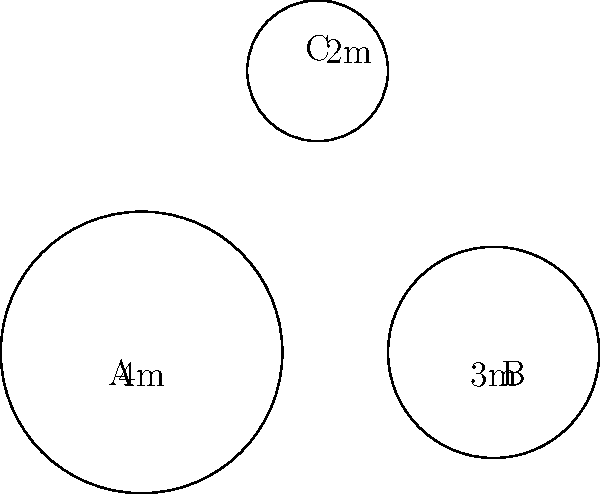You're planning to install three circular cold storage units in your online grocery store to keep fresh produce at optimal temperatures. The radii of the units are 4m, 3m, and 2m respectively, as shown in the diagram. Calculate the total floor area that these cold storage units will occupy. Round your answer to the nearest square meter. To solve this problem, we need to calculate the area of each circular cold storage unit and then sum them up. Let's go through this step-by-step:

1) The formula for the area of a circle is $A = \pi r^2$, where $r$ is the radius.

2) For the first unit (A):
   $A_1 = \pi (4m)^2 = 16\pi m^2$

3) For the second unit (B):
   $A_2 = \pi (3m)^2 = 9\pi m^2$

4) For the third unit (C):
   $A_3 = \pi (2m)^2 = 4\pi m^2$

5) Total area:
   $A_{total} = A_1 + A_2 + A_3$
   $A_{total} = 16\pi m^2 + 9\pi m^2 + 4\pi m^2$
   $A_{total} = 29\pi m^2$

6) Now, let's calculate this:
   $A_{total} = 29 \times 3.14159... \approx 91.1 m^2$

7) Rounding to the nearest square meter:
   $A_{total} \approx 91 m^2$

Therefore, the total floor area occupied by the cold storage units will be approximately 91 square meters.
Answer: 91 $m^2$ 